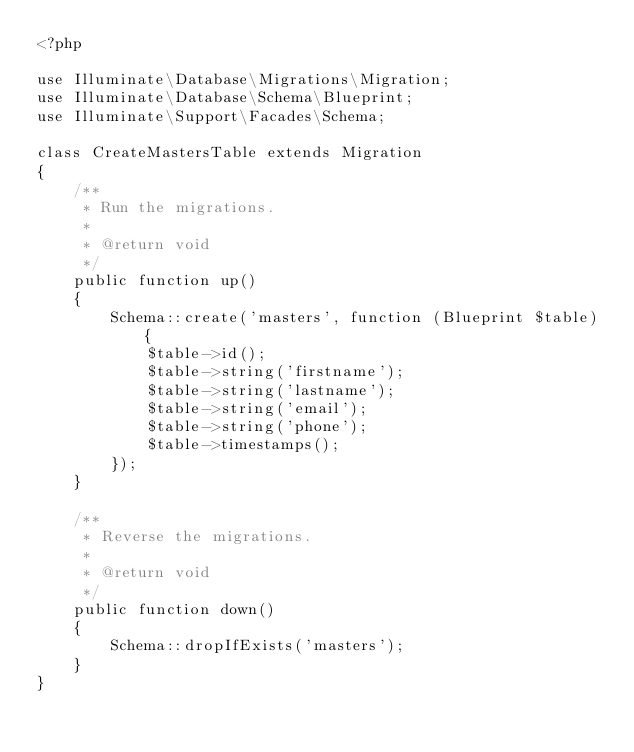Convert code to text. <code><loc_0><loc_0><loc_500><loc_500><_PHP_><?php

use Illuminate\Database\Migrations\Migration;
use Illuminate\Database\Schema\Blueprint;
use Illuminate\Support\Facades\Schema;

class CreateMastersTable extends Migration
{
    /**
     * Run the migrations.
     *
     * @return void
     */
    public function up()
    {
        Schema::create('masters', function (Blueprint $table) {
            $table->id();
            $table->string('firstname');
            $table->string('lastname');
            $table->string('email');
            $table->string('phone');
            $table->timestamps();
        });
    }

    /**
     * Reverse the migrations.
     *
     * @return void
     */
    public function down()
    {
        Schema::dropIfExists('masters');
    }
}
</code> 